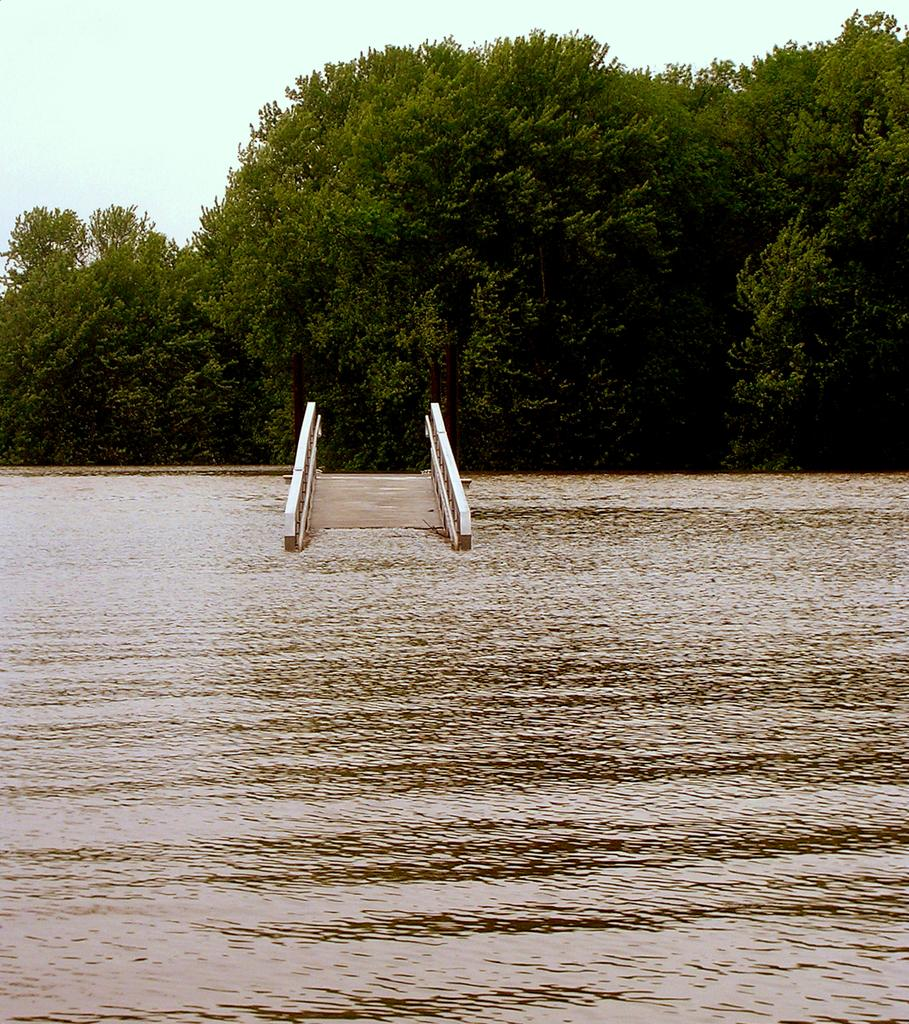What structure can be seen in the image? There is a bridge in the image. Where is the bridge located? The bridge is in the water. What else can be seen in the middle of the image? There are trees in the middle of the image. What is visible at the top of the image? The sky is visible at the top of the image. What is the chance of winning a lottery in the image? There is no mention of a lottery or any chance of winning in the image. 